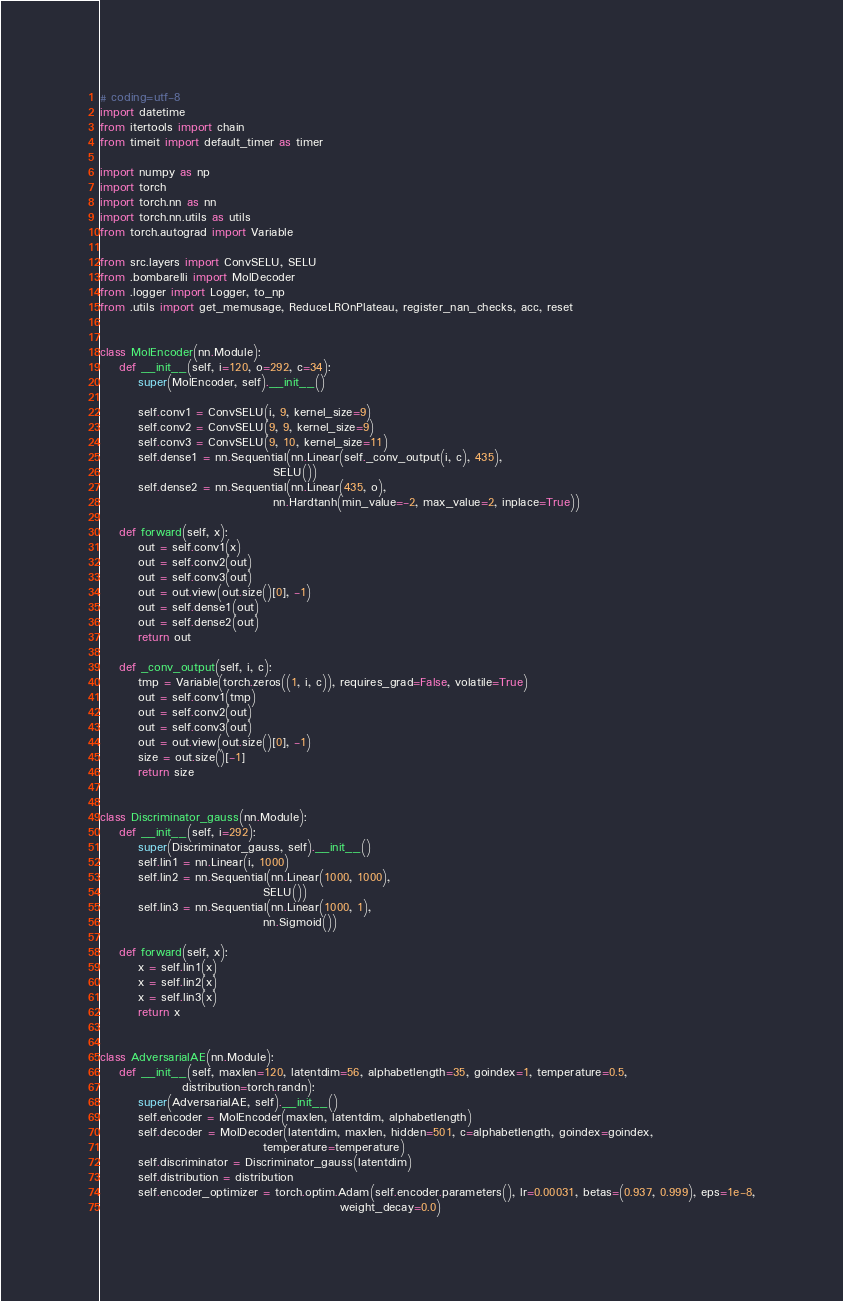Convert code to text. <code><loc_0><loc_0><loc_500><loc_500><_Python_># coding=utf-8
import datetime
from itertools import chain
from timeit import default_timer as timer

import numpy as np
import torch
import torch.nn as nn
import torch.nn.utils as utils
from torch.autograd import Variable

from src.layers import ConvSELU, SELU
from .bombarelli import MolDecoder
from .logger import Logger, to_np
from .utils import get_memusage, ReduceLROnPlateau, register_nan_checks, acc, reset


class MolEncoder(nn.Module):
    def __init__(self, i=120, o=292, c=34):
        super(MolEncoder, self).__init__()

        self.conv1 = ConvSELU(i, 9, kernel_size=9)
        self.conv2 = ConvSELU(9, 9, kernel_size=9)
        self.conv3 = ConvSELU(9, 10, kernel_size=11)
        self.dense1 = nn.Sequential(nn.Linear(self._conv_output(i, c), 435),
                                    SELU())
        self.dense2 = nn.Sequential(nn.Linear(435, o),
                                    nn.Hardtanh(min_value=-2, max_value=2, inplace=True))

    def forward(self, x):
        out = self.conv1(x)
        out = self.conv2(out)
        out = self.conv3(out)
        out = out.view(out.size()[0], -1)
        out = self.dense1(out)
        out = self.dense2(out)
        return out

    def _conv_output(self, i, c):
        tmp = Variable(torch.zeros((1, i, c)), requires_grad=False, volatile=True)
        out = self.conv1(tmp)
        out = self.conv2(out)
        out = self.conv3(out)
        out = out.view(out.size()[0], -1)
        size = out.size()[-1]
        return size


class Discriminator_gauss(nn.Module):
    def __init__(self, i=292):
        super(Discriminator_gauss, self).__init__()
        self.lin1 = nn.Linear(i, 1000)
        self.lin2 = nn.Sequential(nn.Linear(1000, 1000),
                                  SELU())
        self.lin3 = nn.Sequential(nn.Linear(1000, 1),
                                  nn.Sigmoid())

    def forward(self, x):
        x = self.lin1(x)
        x = self.lin2(x)
        x = self.lin3(x)
        return x


class AdversarialAE(nn.Module):
    def __init__(self, maxlen=120, latentdim=56, alphabetlength=35, goindex=1, temperature=0.5,
                 distribution=torch.randn):
        super(AdversarialAE, self).__init__()
        self.encoder = MolEncoder(maxlen, latentdim, alphabetlength)
        self.decoder = MolDecoder(latentdim, maxlen, hidden=501, c=alphabetlength, goindex=goindex,
                                  temperature=temperature)
        self.discriminator = Discriminator_gauss(latentdim)
        self.distribution = distribution
        self.encoder_optimizer = torch.optim.Adam(self.encoder.parameters(), lr=0.00031, betas=(0.937, 0.999), eps=1e-8,
                                                  weight_decay=0.0)</code> 